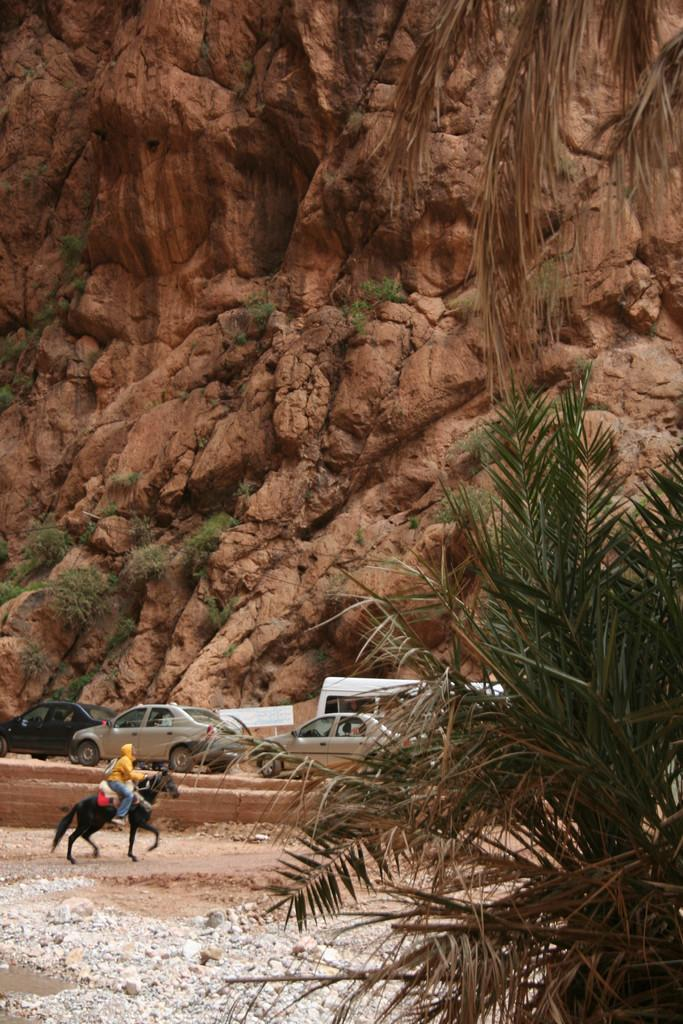What is the main feature in the center of the image? There is a hill in the center of the image. What type of natural elements can be seen in the image? There are plants, trees, and stones in the image. What man-made objects are present in the image? There are vehicles and a board in the image. Is there any sign of human activity in the image? Yes, there is a person riding a horse in the image. How many ants can be seen carrying the rock in the image? There are no ants or rocks present in the image. What is the chance of winning the lottery based on the image? The image does not provide any information about the lottery or chances of winning. 